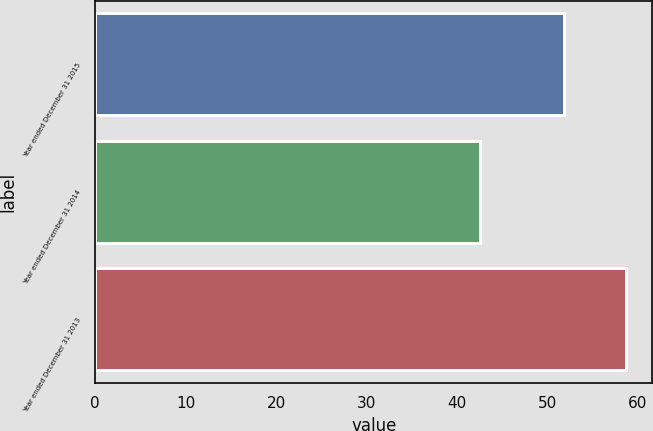Convert chart to OTSL. <chart><loc_0><loc_0><loc_500><loc_500><bar_chart><fcel>Year ended December 31 2015<fcel>Year ended December 31 2014<fcel>Year ended December 31 2013<nl><fcel>51.8<fcel>42.5<fcel>58.7<nl></chart> 